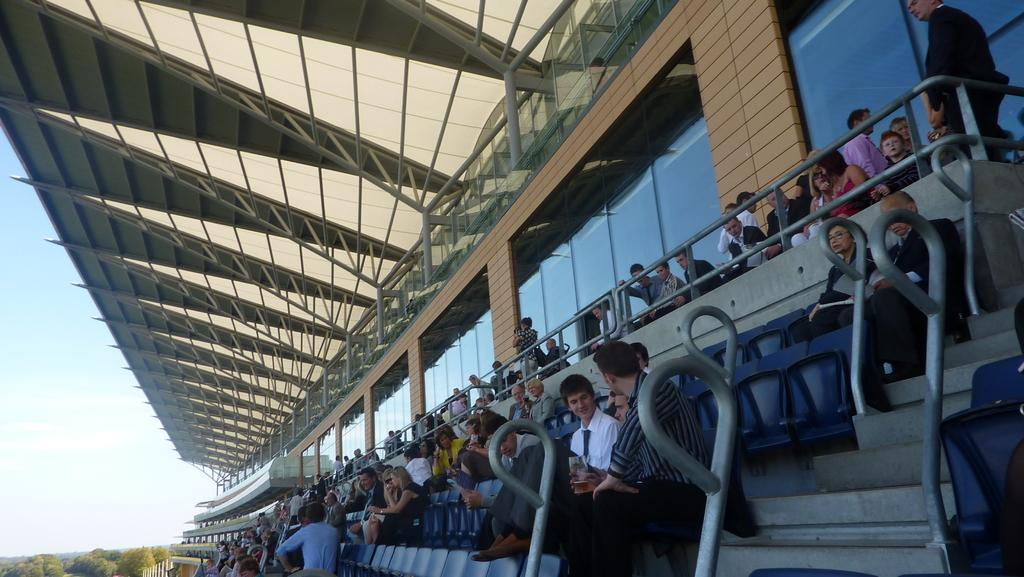What are the people in the image doing? There are many people sitting on chairs and people standing in the image. What can be seen in the background of the image? There is a wall, a window, and a pole at the rooftop in the background. What is on the left side of the image? There are trees on the left side of the image. What is visible in the sky in the image? The sky is visible in the image. What type of competition is taking place in the image? There is no competition present in the image. How does the digestion process of the people in the image appear to be? There is no information about the digestion process of the people in the image. 